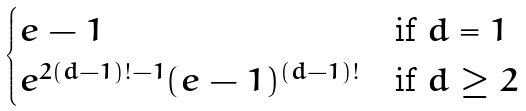Convert formula to latex. <formula><loc_0><loc_0><loc_500><loc_500>\begin{cases} e - 1 & \text {if } d = 1 \\ e ^ { 2 ( d - 1 ) ! - 1 } ( e - 1 ) ^ { ( d - 1 ) ! } & \text {if } d \geq 2 \end{cases}</formula> 